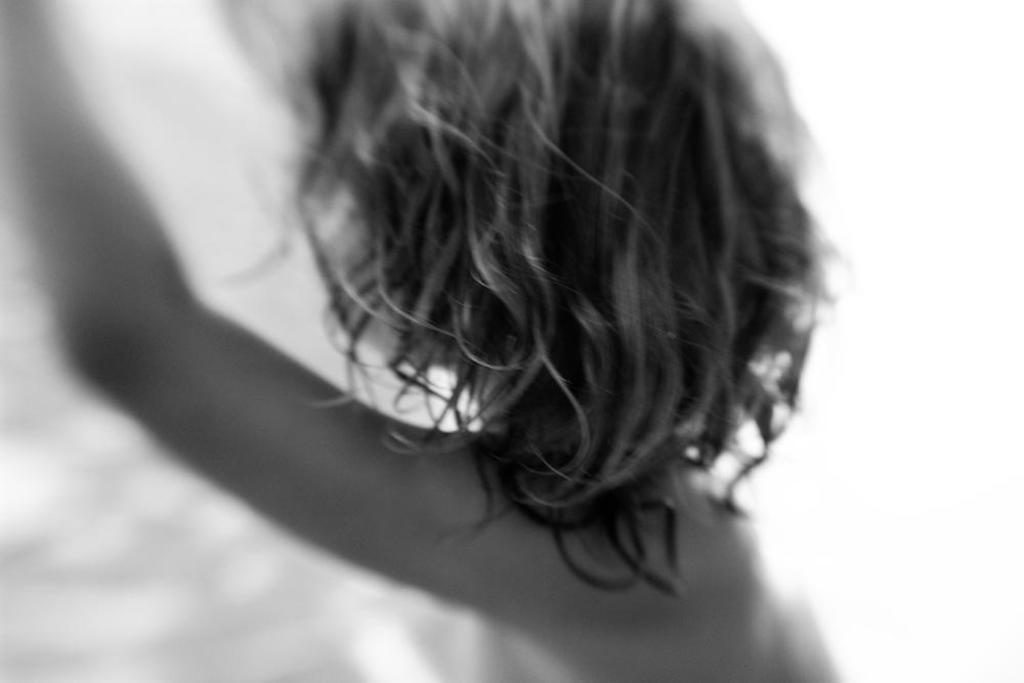What is the main subject of the image? There is a person in the image. What is the chance of seeing a star in the image? There is no mention of a star in the image, so it cannot be determined if there is a chance of seeing one. 